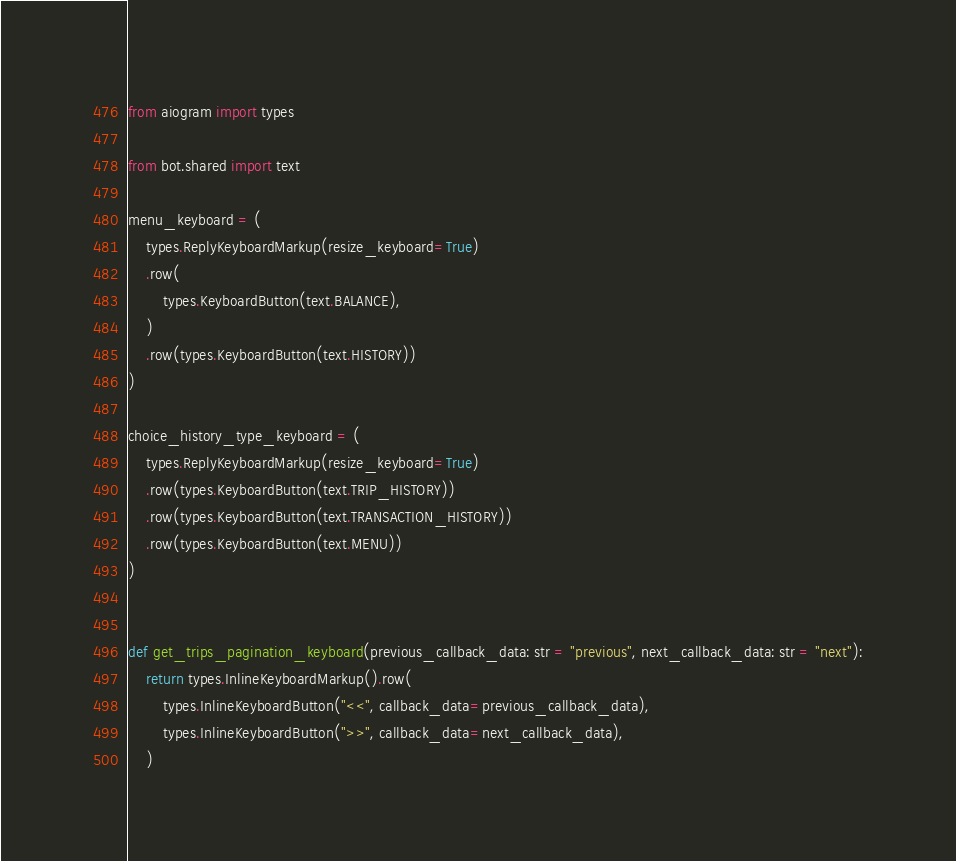<code> <loc_0><loc_0><loc_500><loc_500><_Python_>from aiogram import types

from bot.shared import text

menu_keyboard = (
    types.ReplyKeyboardMarkup(resize_keyboard=True)
    .row(
        types.KeyboardButton(text.BALANCE),
    )
    .row(types.KeyboardButton(text.HISTORY))
)

choice_history_type_keyboard = (
    types.ReplyKeyboardMarkup(resize_keyboard=True)
    .row(types.KeyboardButton(text.TRIP_HISTORY))
    .row(types.KeyboardButton(text.TRANSACTION_HISTORY))
    .row(types.KeyboardButton(text.MENU))
)


def get_trips_pagination_keyboard(previous_callback_data: str = "previous", next_callback_data: str = "next"):
    return types.InlineKeyboardMarkup().row(
        types.InlineKeyboardButton("<<", callback_data=previous_callback_data),
        types.InlineKeyboardButton(">>", callback_data=next_callback_data),
    )
</code> 